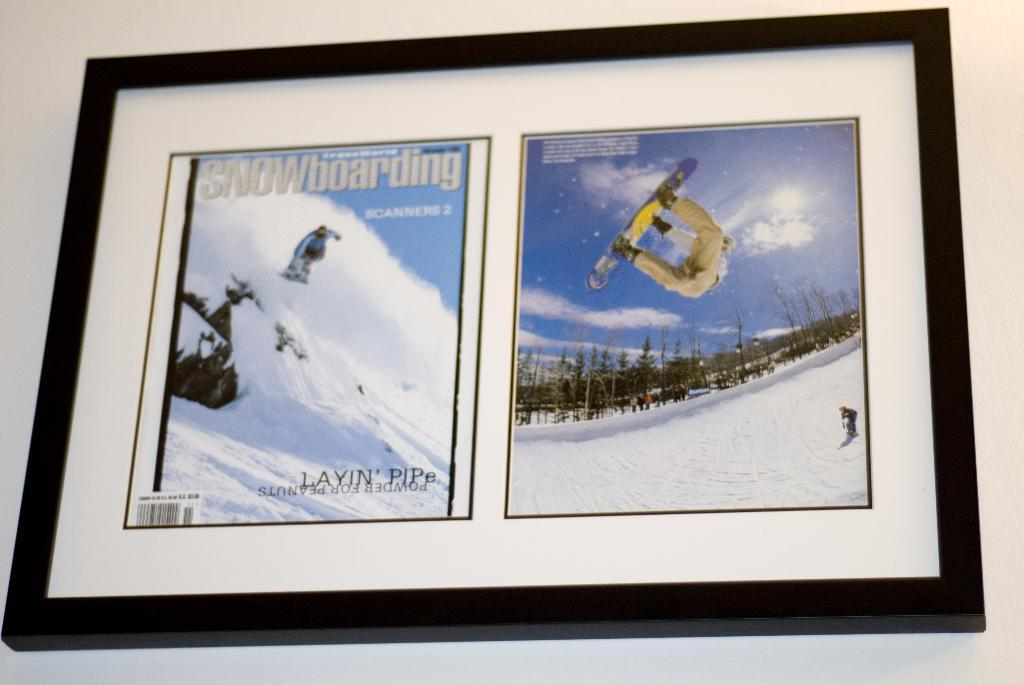<image>
Share a concise interpretation of the image provided. A framed copy of Snowboarding Magazine with the image of a person on a snowboard doing a flip. 